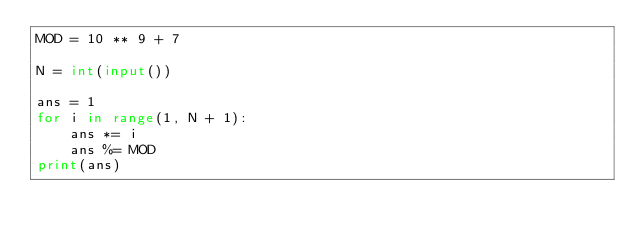Convert code to text. <code><loc_0><loc_0><loc_500><loc_500><_Python_>MOD = 10 ** 9 + 7

N = int(input())

ans = 1
for i in range(1, N + 1):
    ans *= i
    ans %= MOD
print(ans)
</code> 